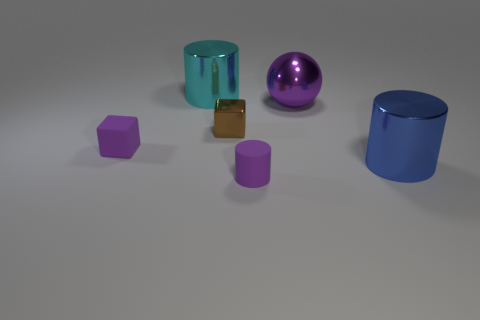Are there any other things that are the same shape as the large purple object?
Offer a terse response. No. How many things are either blue metal spheres or purple objects in front of the small rubber block?
Your answer should be compact. 1. There is a small purple thing that is to the left of the big cyan shiny thing; is it the same shape as the small brown metallic object that is in front of the cyan thing?
Ensure brevity in your answer.  Yes. What number of objects are small purple rubber blocks or big cyan metallic cylinders?
Your response must be concise. 2. Are there any large shiny things?
Provide a short and direct response. Yes. Does the small purple object in front of the small purple matte cube have the same material as the tiny brown object?
Offer a terse response. No. Is there a large red metallic thing that has the same shape as the tiny brown thing?
Provide a succinct answer. No. Are there an equal number of small brown metallic cubes on the left side of the large cyan metallic thing and red rubber balls?
Your response must be concise. Yes. What is the cylinder behind the big cylinder to the right of the purple metal ball made of?
Make the answer very short. Metal. There is a brown object; what shape is it?
Your answer should be very brief. Cube. 